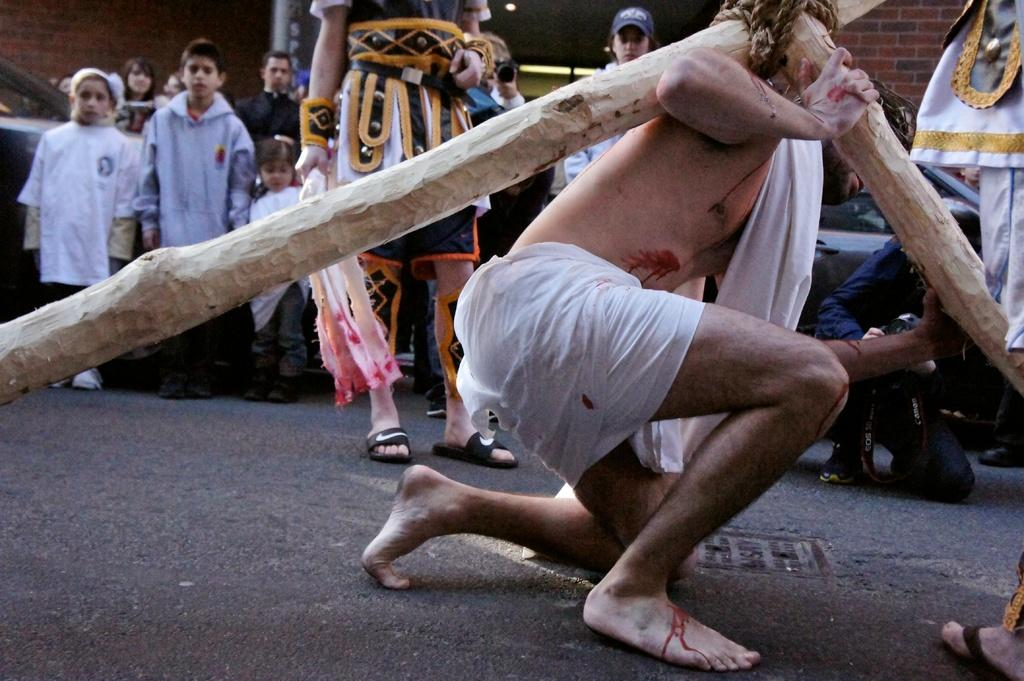What is: What is the person in the image doing? The person is sitting on his knees in the image. What is the person holding on his shoulder? The person is holding wooden sticks on his shoulder. Are there any other people in the image? Yes, there are people standing behind the person holding wooden sticks. Can you describe the actions of the people standing behind the person? The people are standing behind the person holding wooden sticks, but one person is holding a camera among them. Can you tell me how many giraffes are present in the image? There are no giraffes present in the image. Is the person's uncle holding the wooden sticks in the image? The facts provided do not mention any relationship between the person and the person holding the wooden sticks, so we cannot determine if it is the person's uncle. --- Facts: 1. There is a person standing on a bridge in the image. 2. The person is holding a fishing rod. 3. There is a river flowing under the bridge. 4. The sky is visible in the image. Absurd Topics: parrot, bicycle, volcano Conversation: What is the person in the image doing? The person is standing on a bridge in the image. What is the person holding? The person is holding a fishing rod. What can be seen under the bridge? There is a river flowing under the bridge. What is visible in the background of the image? The sky is visible in the image. Reasoning: Let's think step by step in order to produce the conversation. We start by identifying the main subject in the image, which is the person standing on the bridge. Then, we describe what the person is holding, which is a fishing rod. Next, we acknowledge the presence of a river flowing under the bridge and the sky visible in the background. Each question is designed to elicit a specific detail about the image that is known from the provided facts. Absurd Question/Answer: Can you tell me how many parrots are sitting on the fishing rod in the image? There are no parrots present in the image. Is there a volcano visible in the background of the image? The facts provided do not mention a volcano, so we cannot determine if one is visible in the background. 